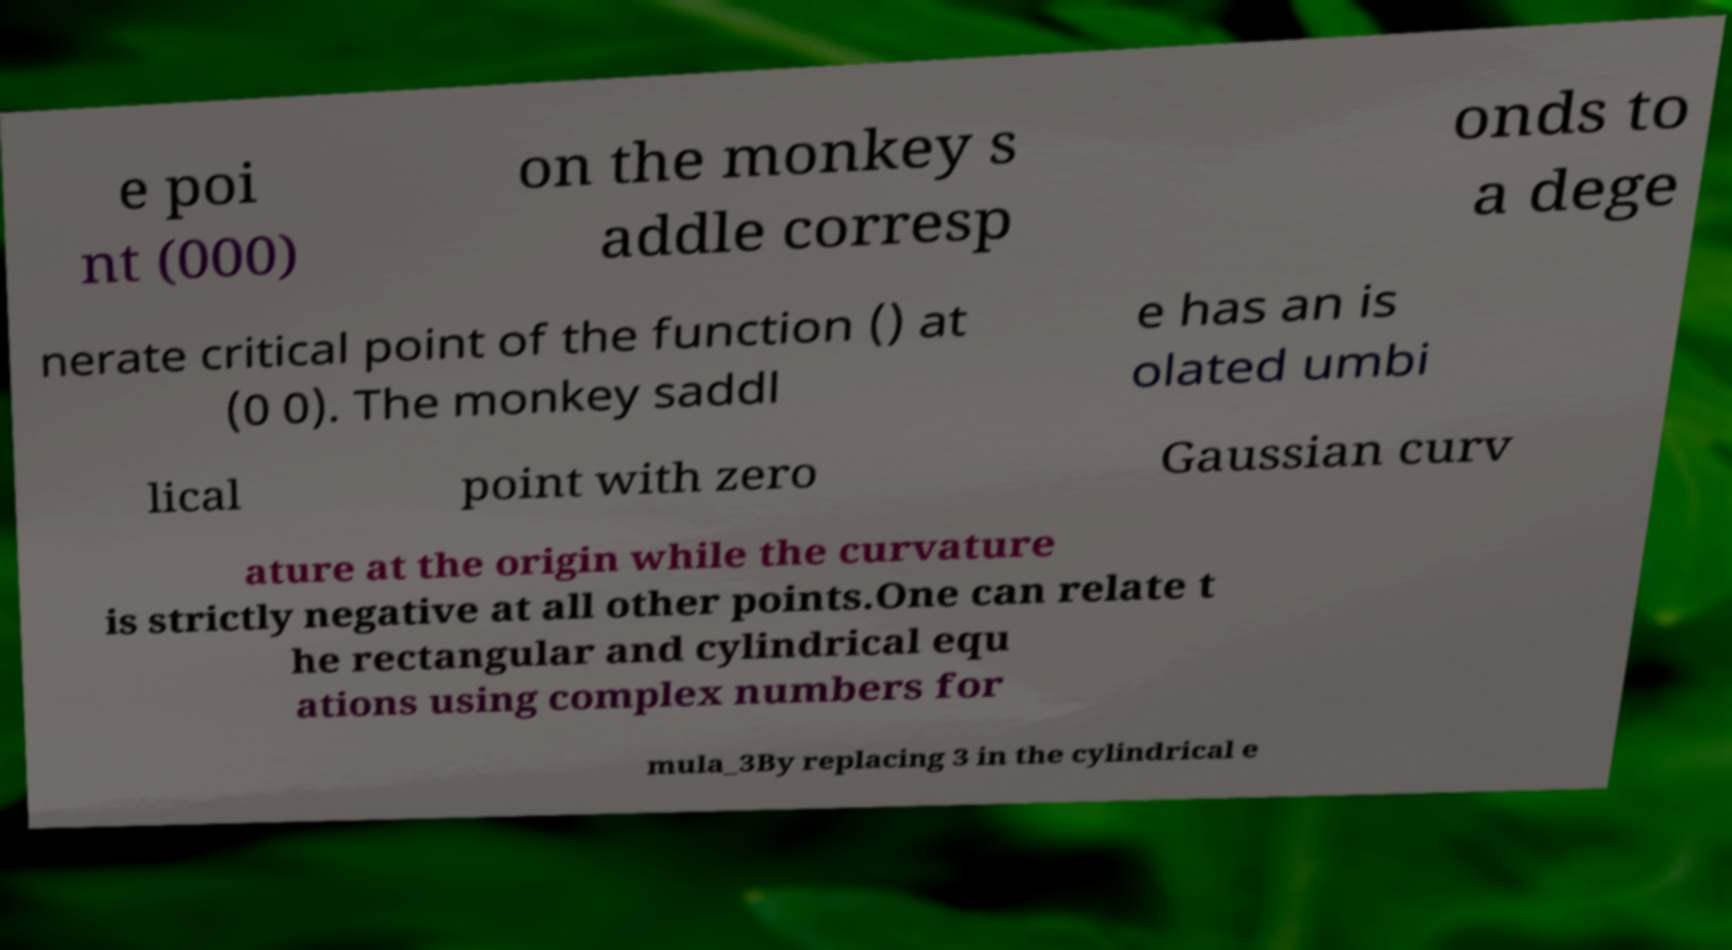Please read and relay the text visible in this image. What does it say? e poi nt (000) on the monkey s addle corresp onds to a dege nerate critical point of the function () at (0 0). The monkey saddl e has an is olated umbi lical point with zero Gaussian curv ature at the origin while the curvature is strictly negative at all other points.One can relate t he rectangular and cylindrical equ ations using complex numbers for mula_3By replacing 3 in the cylindrical e 